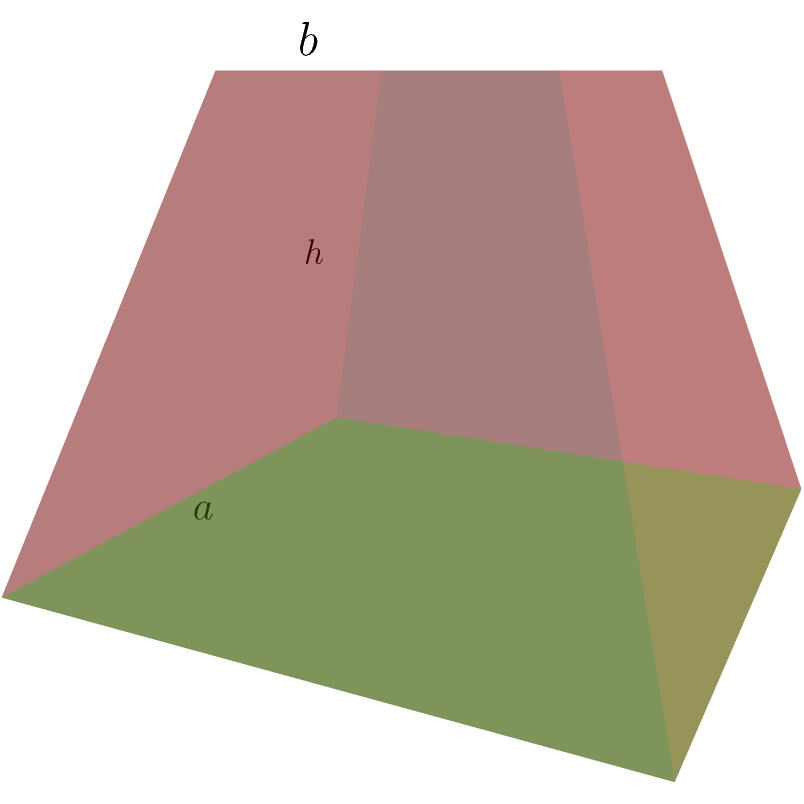A workshop on data visualization requires a unique display stand in the shape of a truncated square pyramid. The base of the pyramid has a side length of 4 units, the top square has a side length of 2 units, and the height of the truncated pyramid is 3 units. Calculate the total surface area of this display stand, including the top and bottom faces. Let's approach this step-by-step:

1) We need to calculate the areas of:
   a) The base square
   b) The top square
   c) The four trapezoid lateral faces

2) Area of the base square:
   $A_{base} = a^2 = 4^2 = 16$ square units

3) Area of the top square:
   $A_{top} = b^2 = 2^2 = 4$ square units

4) For the lateral faces, we need to find:
   a) The slant height
   b) The area of one trapezoid, then multiply by 4

5) To find the slant height (s), we can use the Pythagorean theorem:
   $s^2 = h^2 + (\frac{a-b}{2})^2$
   $s^2 = 3^2 + (\frac{4-2}{2})^2 = 9 + 1 = 10$
   $s = \sqrt{10}$

6) Area of one trapezoid:
   $A_{trapezoid} = \frac{a+b}{2} \cdot s = \frac{4+2}{2} \cdot \sqrt{10} = 3\sqrt{10}$

7) Total area of the four lateral faces:
   $A_{lateral} = 4 \cdot 3\sqrt{10} = 12\sqrt{10}$

8) Total surface area:
   $A_{total} = A_{base} + A_{top} + A_{lateral}$
   $A_{total} = 16 + 4 + 12\sqrt{10}$
   $A_{total} = 20 + 12\sqrt{10}$ square units

Therefore, the total surface area of the truncated pyramid is $20 + 12\sqrt{10}$ square units.
Answer: $20 + 12\sqrt{10}$ square units 